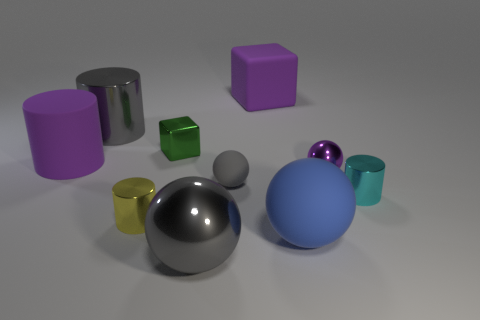Can you tell me the colors of all objects present in the image? Certainly! From left to right, there is a purple cylinder, a silver cylinder, a silver cylinder with a smaller radius, a golden-yellow sphere, a green cube, a darkish gray sphere, a light gray sphere, a large blue sphere, and a small cyan cylinder. 